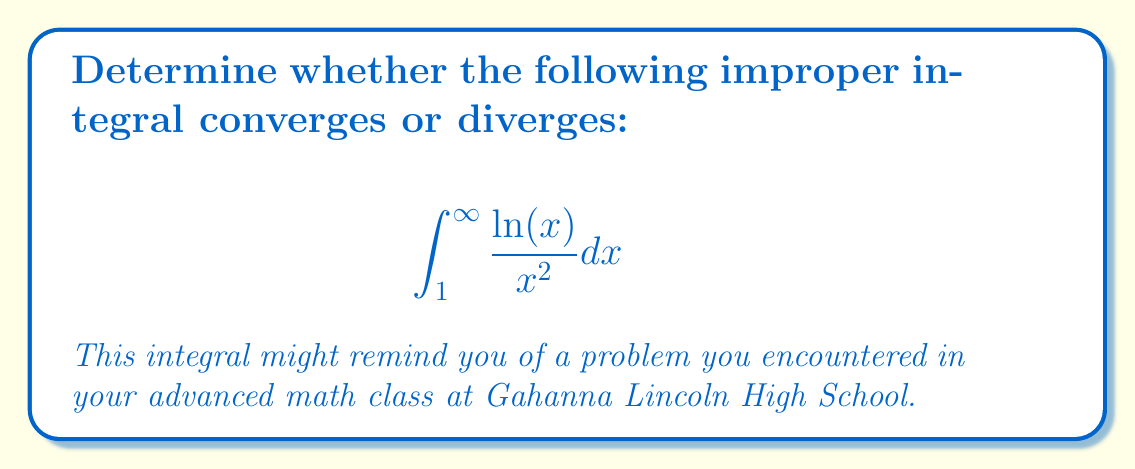What is the answer to this math problem? Let's approach this step-by-step:

1) First, we need to recognize that this is an improper integral of the second kind, as the upper limit is infinity.

2) To evaluate this, we'll use the limit definition of an improper integral:

   $$\int_{1}^{\infty} \frac{\ln(x)}{x^2} dx = \lim_{b \to \infty} \int_{1}^{b} \frac{\ln(x)}{x^2} dx$$

3) To integrate this, we can use integration by parts. Let:
   $u = \ln(x)$, so $du = \frac{1}{x}dx$
   $dv = \frac{1}{x^2}dx$, so $v = -\frac{1}{x}$

4) Applying integration by parts:

   $$\int \frac{\ln(x)}{x^2} dx = \ln(x)(-\frac{1}{x}) - \int (-\frac{1}{x})(\frac{1}{x})dx$$
   
   $$= -\frac{\ln(x)}{x} + \int \frac{1}{x^2}dx$$

5) Evaluating the remaining integral:

   $$= -\frac{\ln(x)}{x} - \frac{1}{x} + C$$

6) Now, let's apply the limits:

   $$\lim_{b \to \infty} \int_{1}^{b} \frac{\ln(x)}{x^2} dx = \lim_{b \to \infty} \left[-\frac{\ln(b)}{b} - \frac{1}{b} + \frac{\ln(1)}{1} + 1\right]$$

7) Simplify:

   $$= \lim_{b \to \infty} \left[-\frac{\ln(b)}{b} - \frac{1}{b} + 1\right]$$

8) As $b \to \infty$, $\frac{1}{b} \to 0$ and $\frac{\ln(b)}{b} \to 0$ (this can be proved using L'Hôpital's rule).

9) Therefore, the limit evaluates to:

   $$\lim_{b \to \infty} \left[-\frac{\ln(b)}{b} - \frac{1}{b} + 1\right] = 0 - 0 + 1 = 1$$

Since this limit exists and is finite, the improper integral converges.
Answer: Converges to 1 